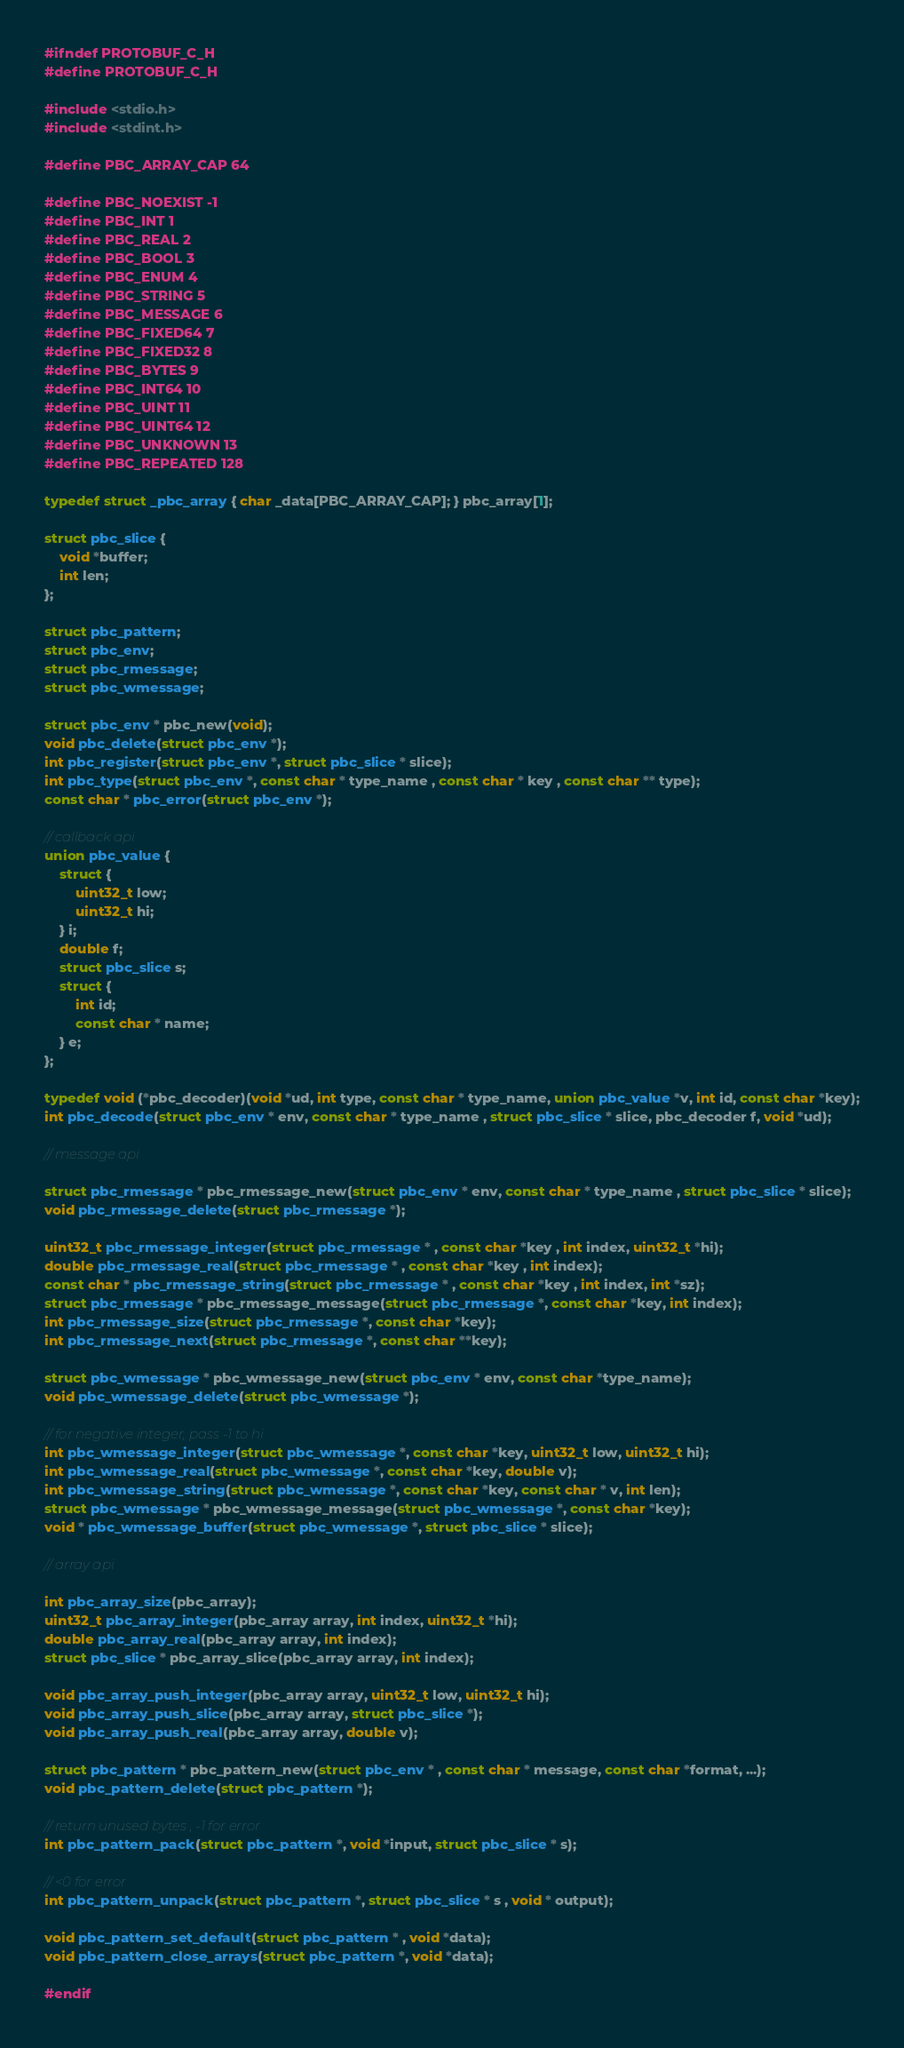<code> <loc_0><loc_0><loc_500><loc_500><_C_>#ifndef PROTOBUF_C_H
#define PROTOBUF_C_H

#include <stdio.h>
#include <stdint.h>

#define PBC_ARRAY_CAP 64

#define PBC_NOEXIST -1
#define PBC_INT 1
#define PBC_REAL 2
#define PBC_BOOL 3
#define PBC_ENUM 4
#define PBC_STRING 5
#define PBC_MESSAGE 6
#define PBC_FIXED64 7
#define PBC_FIXED32 8
#define PBC_BYTES 9
#define PBC_INT64 10
#define PBC_UINT 11
#define PBC_UINT64 12
#define PBC_UNKNOWN 13
#define PBC_REPEATED 128

typedef struct _pbc_array { char _data[PBC_ARRAY_CAP]; } pbc_array[1];

struct pbc_slice {
	void *buffer;
	int len;
};

struct pbc_pattern;
struct pbc_env;
struct pbc_rmessage;
struct pbc_wmessage;

struct pbc_env * pbc_new(void);
void pbc_delete(struct pbc_env *);
int pbc_register(struct pbc_env *, struct pbc_slice * slice);
int pbc_type(struct pbc_env *, const char * type_name , const char * key , const char ** type);
const char * pbc_error(struct pbc_env *);

// callback api
union pbc_value {
	struct {
		uint32_t low;
		uint32_t hi;
	} i;
	double f;
	struct pbc_slice s;
	struct {
		int id;
		const char * name;
	} e;
};

typedef void (*pbc_decoder)(void *ud, int type, const char * type_name, union pbc_value *v, int id, const char *key);
int pbc_decode(struct pbc_env * env, const char * type_name , struct pbc_slice * slice, pbc_decoder f, void *ud);

// message api

struct pbc_rmessage * pbc_rmessage_new(struct pbc_env * env, const char * type_name , struct pbc_slice * slice);
void pbc_rmessage_delete(struct pbc_rmessage *);

uint32_t pbc_rmessage_integer(struct pbc_rmessage * , const char *key , int index, uint32_t *hi);
double pbc_rmessage_real(struct pbc_rmessage * , const char *key , int index);
const char * pbc_rmessage_string(struct pbc_rmessage * , const char *key , int index, int *sz);
struct pbc_rmessage * pbc_rmessage_message(struct pbc_rmessage *, const char *key, int index);
int pbc_rmessage_size(struct pbc_rmessage *, const char *key);
int pbc_rmessage_next(struct pbc_rmessage *, const char **key);

struct pbc_wmessage * pbc_wmessage_new(struct pbc_env * env, const char *type_name);
void pbc_wmessage_delete(struct pbc_wmessage *);

// for negative integer, pass -1 to hi
int pbc_wmessage_integer(struct pbc_wmessage *, const char *key, uint32_t low, uint32_t hi);
int pbc_wmessage_real(struct pbc_wmessage *, const char *key, double v);
int pbc_wmessage_string(struct pbc_wmessage *, const char *key, const char * v, int len);
struct pbc_wmessage * pbc_wmessage_message(struct pbc_wmessage *, const char *key);
void * pbc_wmessage_buffer(struct pbc_wmessage *, struct pbc_slice * slice);

// array api 

int pbc_array_size(pbc_array);
uint32_t pbc_array_integer(pbc_array array, int index, uint32_t *hi);
double pbc_array_real(pbc_array array, int index);
struct pbc_slice * pbc_array_slice(pbc_array array, int index);

void pbc_array_push_integer(pbc_array array, uint32_t low, uint32_t hi);
void pbc_array_push_slice(pbc_array array, struct pbc_slice *);
void pbc_array_push_real(pbc_array array, double v);

struct pbc_pattern * pbc_pattern_new(struct pbc_env * , const char * message, const char *format, ...);
void pbc_pattern_delete(struct pbc_pattern *);

// return unused bytes , -1 for error
int pbc_pattern_pack(struct pbc_pattern *, void *input, struct pbc_slice * s);

// <0 for error
int pbc_pattern_unpack(struct pbc_pattern *, struct pbc_slice * s , void * output);

void pbc_pattern_set_default(struct pbc_pattern * , void *data);
void pbc_pattern_close_arrays(struct pbc_pattern *, void *data);

#endif
</code> 